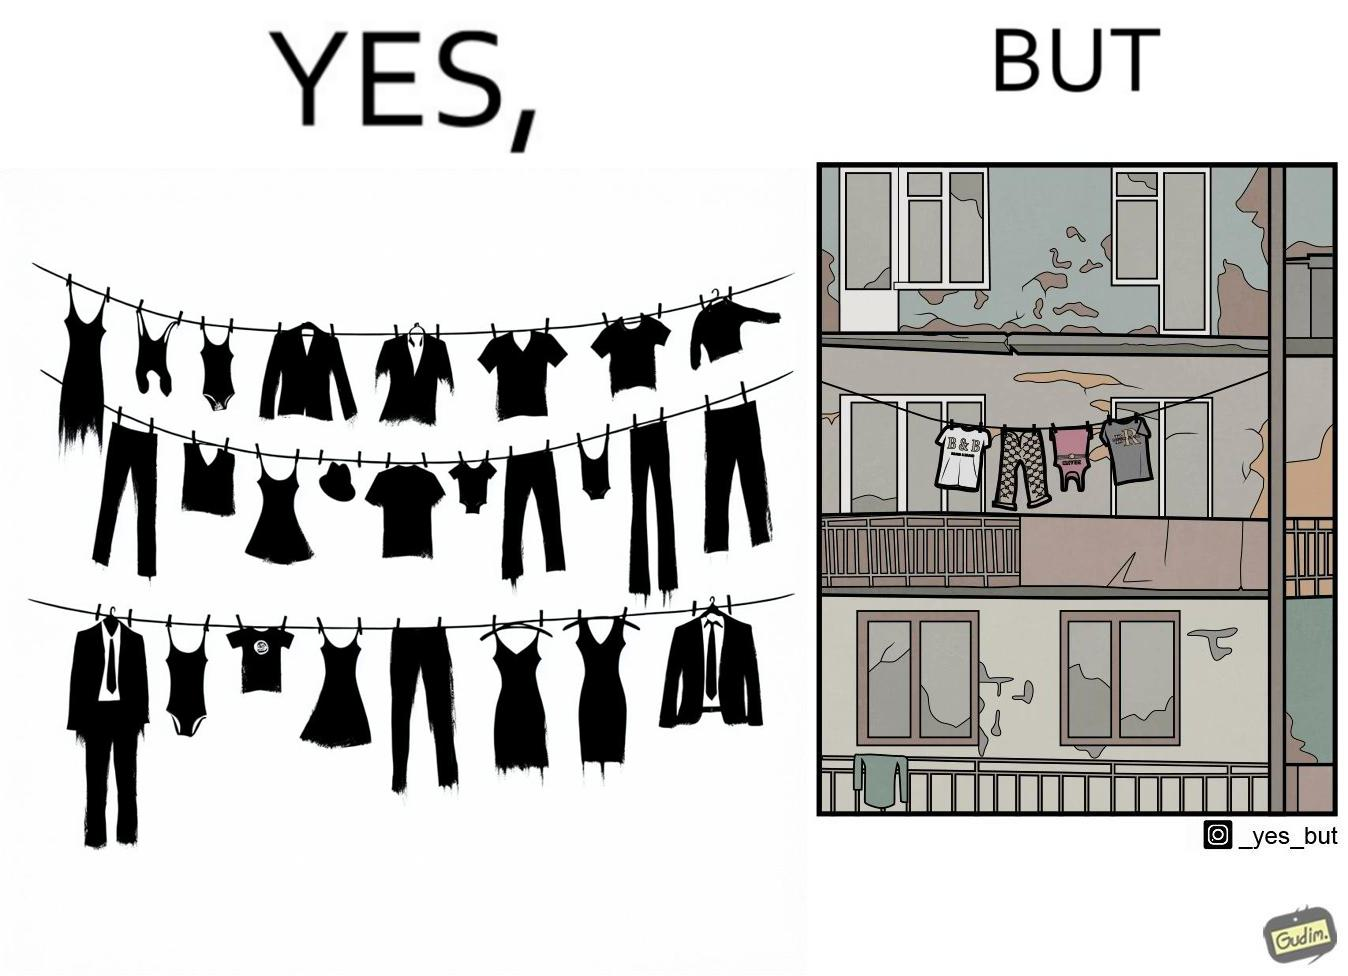Is this image satirical or non-satirical? Yes, this image is satirical. 